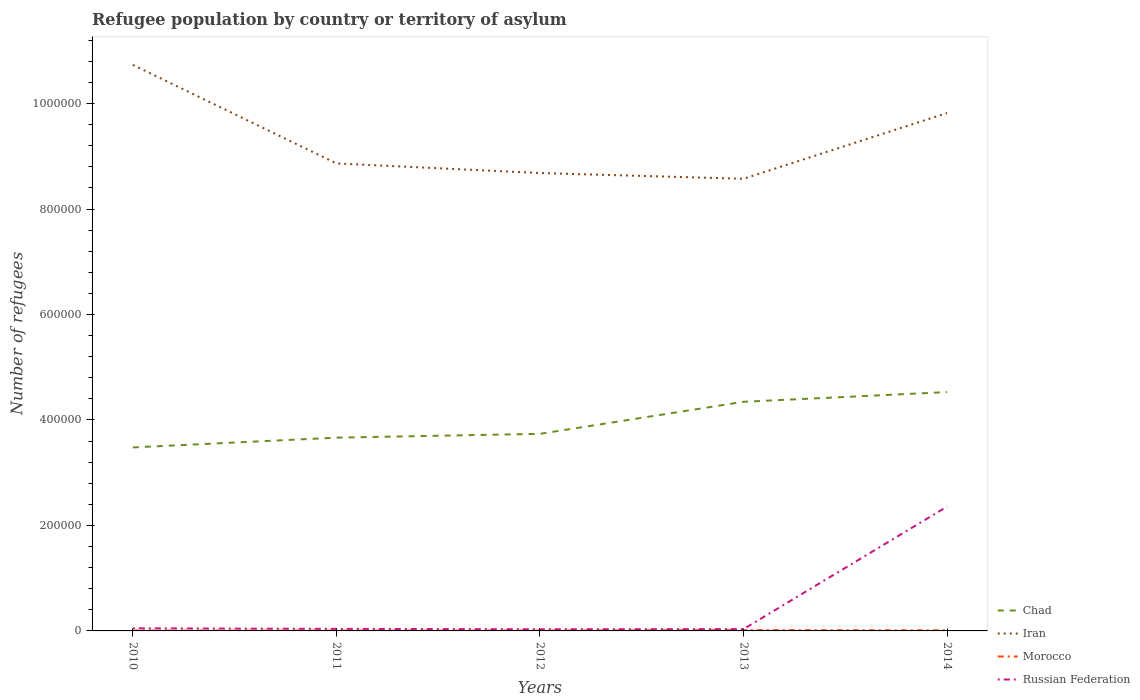Does the line corresponding to Morocco intersect with the line corresponding to Chad?
Offer a very short reply. No. Is the number of lines equal to the number of legend labels?
Your response must be concise. Yes. Across all years, what is the maximum number of refugees in Russian Federation?
Offer a terse response. 3178. In which year was the number of refugees in Morocco maximum?
Provide a short and direct response. 2011. What is the total number of refugees in Russian Federation in the graph?
Offer a very short reply. 1744. What is the difference between the highest and the second highest number of refugees in Iran?
Offer a terse response. 2.16e+05. How many lines are there?
Ensure brevity in your answer.  4. What is the difference between two consecutive major ticks on the Y-axis?
Your answer should be compact. 2.00e+05. Where does the legend appear in the graph?
Offer a very short reply. Bottom right. What is the title of the graph?
Make the answer very short. Refugee population by country or territory of asylum. What is the label or title of the Y-axis?
Give a very brief answer. Number of refugees. What is the Number of refugees in Chad in 2010?
Your response must be concise. 3.48e+05. What is the Number of refugees in Iran in 2010?
Your answer should be very brief. 1.07e+06. What is the Number of refugees in Morocco in 2010?
Your answer should be compact. 792. What is the Number of refugees in Russian Federation in 2010?
Your response must be concise. 4922. What is the Number of refugees in Chad in 2011?
Provide a short and direct response. 3.66e+05. What is the Number of refugees of Iran in 2011?
Offer a very short reply. 8.86e+05. What is the Number of refugees of Morocco in 2011?
Ensure brevity in your answer.  736. What is the Number of refugees of Russian Federation in 2011?
Provide a short and direct response. 3914. What is the Number of refugees of Chad in 2012?
Provide a short and direct response. 3.74e+05. What is the Number of refugees of Iran in 2012?
Keep it short and to the point. 8.68e+05. What is the Number of refugees of Morocco in 2012?
Provide a short and direct response. 744. What is the Number of refugees in Russian Federation in 2012?
Make the answer very short. 3178. What is the Number of refugees of Chad in 2013?
Provide a succinct answer. 4.34e+05. What is the Number of refugees in Iran in 2013?
Provide a succinct answer. 8.57e+05. What is the Number of refugees of Morocco in 2013?
Give a very brief answer. 1470. What is the Number of refugees in Russian Federation in 2013?
Keep it short and to the point. 3458. What is the Number of refugees in Chad in 2014?
Make the answer very short. 4.53e+05. What is the Number of refugees in Iran in 2014?
Provide a succinct answer. 9.82e+05. What is the Number of refugees of Morocco in 2014?
Ensure brevity in your answer.  1216. What is the Number of refugees of Russian Federation in 2014?
Ensure brevity in your answer.  2.36e+05. Across all years, what is the maximum Number of refugees in Chad?
Your response must be concise. 4.53e+05. Across all years, what is the maximum Number of refugees in Iran?
Offer a very short reply. 1.07e+06. Across all years, what is the maximum Number of refugees of Morocco?
Give a very brief answer. 1470. Across all years, what is the maximum Number of refugees of Russian Federation?
Offer a very short reply. 2.36e+05. Across all years, what is the minimum Number of refugees of Chad?
Offer a terse response. 3.48e+05. Across all years, what is the minimum Number of refugees of Iran?
Your answer should be very brief. 8.57e+05. Across all years, what is the minimum Number of refugees in Morocco?
Keep it short and to the point. 736. Across all years, what is the minimum Number of refugees of Russian Federation?
Offer a terse response. 3178. What is the total Number of refugees of Chad in the graph?
Keep it short and to the point. 1.98e+06. What is the total Number of refugees of Iran in the graph?
Provide a short and direct response. 4.67e+06. What is the total Number of refugees of Morocco in the graph?
Give a very brief answer. 4958. What is the total Number of refugees in Russian Federation in the graph?
Your response must be concise. 2.51e+05. What is the difference between the Number of refugees of Chad in 2010 and that in 2011?
Provide a succinct answer. -1.86e+04. What is the difference between the Number of refugees in Iran in 2010 and that in 2011?
Ensure brevity in your answer.  1.87e+05. What is the difference between the Number of refugees in Morocco in 2010 and that in 2011?
Keep it short and to the point. 56. What is the difference between the Number of refugees of Russian Federation in 2010 and that in 2011?
Your answer should be very brief. 1008. What is the difference between the Number of refugees in Chad in 2010 and that in 2012?
Your answer should be very brief. -2.58e+04. What is the difference between the Number of refugees in Iran in 2010 and that in 2012?
Make the answer very short. 2.05e+05. What is the difference between the Number of refugees of Russian Federation in 2010 and that in 2012?
Give a very brief answer. 1744. What is the difference between the Number of refugees in Chad in 2010 and that in 2013?
Your answer should be very brief. -8.65e+04. What is the difference between the Number of refugees in Iran in 2010 and that in 2013?
Give a very brief answer. 2.16e+05. What is the difference between the Number of refugees of Morocco in 2010 and that in 2013?
Provide a succinct answer. -678. What is the difference between the Number of refugees of Russian Federation in 2010 and that in 2013?
Your response must be concise. 1464. What is the difference between the Number of refugees of Chad in 2010 and that in 2014?
Give a very brief answer. -1.05e+05. What is the difference between the Number of refugees of Iran in 2010 and that in 2014?
Give a very brief answer. 9.13e+04. What is the difference between the Number of refugees in Morocco in 2010 and that in 2014?
Offer a terse response. -424. What is the difference between the Number of refugees in Russian Federation in 2010 and that in 2014?
Your answer should be very brief. -2.31e+05. What is the difference between the Number of refugees in Chad in 2011 and that in 2012?
Offer a terse response. -7201. What is the difference between the Number of refugees of Iran in 2011 and that in 2012?
Your answer should be compact. 1.82e+04. What is the difference between the Number of refugees of Russian Federation in 2011 and that in 2012?
Give a very brief answer. 736. What is the difference between the Number of refugees of Chad in 2011 and that in 2013?
Your answer should be compact. -6.80e+04. What is the difference between the Number of refugees in Iran in 2011 and that in 2013?
Provide a succinct answer. 2.91e+04. What is the difference between the Number of refugees of Morocco in 2011 and that in 2013?
Your response must be concise. -734. What is the difference between the Number of refugees in Russian Federation in 2011 and that in 2013?
Make the answer very short. 456. What is the difference between the Number of refugees in Chad in 2011 and that in 2014?
Your answer should be compact. -8.64e+04. What is the difference between the Number of refugees in Iran in 2011 and that in 2014?
Make the answer very short. -9.56e+04. What is the difference between the Number of refugees in Morocco in 2011 and that in 2014?
Your answer should be compact. -480. What is the difference between the Number of refugees in Russian Federation in 2011 and that in 2014?
Make the answer very short. -2.32e+05. What is the difference between the Number of refugees in Chad in 2012 and that in 2013?
Your response must be concise. -6.08e+04. What is the difference between the Number of refugees in Iran in 2012 and that in 2013?
Give a very brief answer. 1.09e+04. What is the difference between the Number of refugees of Morocco in 2012 and that in 2013?
Your answer should be very brief. -726. What is the difference between the Number of refugees of Russian Federation in 2012 and that in 2013?
Make the answer very short. -280. What is the difference between the Number of refugees in Chad in 2012 and that in 2014?
Ensure brevity in your answer.  -7.92e+04. What is the difference between the Number of refugees of Iran in 2012 and that in 2014?
Offer a terse response. -1.14e+05. What is the difference between the Number of refugees in Morocco in 2012 and that in 2014?
Give a very brief answer. -472. What is the difference between the Number of refugees of Russian Federation in 2012 and that in 2014?
Your response must be concise. -2.33e+05. What is the difference between the Number of refugees of Chad in 2013 and that in 2014?
Keep it short and to the point. -1.84e+04. What is the difference between the Number of refugees in Iran in 2013 and that in 2014?
Your answer should be very brief. -1.25e+05. What is the difference between the Number of refugees in Morocco in 2013 and that in 2014?
Provide a succinct answer. 254. What is the difference between the Number of refugees of Russian Federation in 2013 and that in 2014?
Provide a short and direct response. -2.32e+05. What is the difference between the Number of refugees of Chad in 2010 and the Number of refugees of Iran in 2011?
Your answer should be very brief. -5.39e+05. What is the difference between the Number of refugees of Chad in 2010 and the Number of refugees of Morocco in 2011?
Give a very brief answer. 3.47e+05. What is the difference between the Number of refugees of Chad in 2010 and the Number of refugees of Russian Federation in 2011?
Your answer should be compact. 3.44e+05. What is the difference between the Number of refugees of Iran in 2010 and the Number of refugees of Morocco in 2011?
Ensure brevity in your answer.  1.07e+06. What is the difference between the Number of refugees of Iran in 2010 and the Number of refugees of Russian Federation in 2011?
Provide a short and direct response. 1.07e+06. What is the difference between the Number of refugees in Morocco in 2010 and the Number of refugees in Russian Federation in 2011?
Give a very brief answer. -3122. What is the difference between the Number of refugees in Chad in 2010 and the Number of refugees in Iran in 2012?
Your answer should be very brief. -5.20e+05. What is the difference between the Number of refugees of Chad in 2010 and the Number of refugees of Morocco in 2012?
Offer a very short reply. 3.47e+05. What is the difference between the Number of refugees in Chad in 2010 and the Number of refugees in Russian Federation in 2012?
Offer a very short reply. 3.45e+05. What is the difference between the Number of refugees of Iran in 2010 and the Number of refugees of Morocco in 2012?
Your answer should be very brief. 1.07e+06. What is the difference between the Number of refugees in Iran in 2010 and the Number of refugees in Russian Federation in 2012?
Give a very brief answer. 1.07e+06. What is the difference between the Number of refugees of Morocco in 2010 and the Number of refugees of Russian Federation in 2012?
Offer a terse response. -2386. What is the difference between the Number of refugees in Chad in 2010 and the Number of refugees in Iran in 2013?
Provide a succinct answer. -5.09e+05. What is the difference between the Number of refugees in Chad in 2010 and the Number of refugees in Morocco in 2013?
Offer a very short reply. 3.46e+05. What is the difference between the Number of refugees in Chad in 2010 and the Number of refugees in Russian Federation in 2013?
Make the answer very short. 3.44e+05. What is the difference between the Number of refugees of Iran in 2010 and the Number of refugees of Morocco in 2013?
Provide a short and direct response. 1.07e+06. What is the difference between the Number of refugees of Iran in 2010 and the Number of refugees of Russian Federation in 2013?
Offer a very short reply. 1.07e+06. What is the difference between the Number of refugees of Morocco in 2010 and the Number of refugees of Russian Federation in 2013?
Make the answer very short. -2666. What is the difference between the Number of refugees of Chad in 2010 and the Number of refugees of Iran in 2014?
Provide a short and direct response. -6.34e+05. What is the difference between the Number of refugees of Chad in 2010 and the Number of refugees of Morocco in 2014?
Offer a terse response. 3.47e+05. What is the difference between the Number of refugees of Chad in 2010 and the Number of refugees of Russian Federation in 2014?
Provide a succinct answer. 1.12e+05. What is the difference between the Number of refugees in Iran in 2010 and the Number of refugees in Morocco in 2014?
Make the answer very short. 1.07e+06. What is the difference between the Number of refugees in Iran in 2010 and the Number of refugees in Russian Federation in 2014?
Ensure brevity in your answer.  8.38e+05. What is the difference between the Number of refugees in Morocco in 2010 and the Number of refugees in Russian Federation in 2014?
Offer a very short reply. -2.35e+05. What is the difference between the Number of refugees of Chad in 2011 and the Number of refugees of Iran in 2012?
Provide a short and direct response. -5.02e+05. What is the difference between the Number of refugees in Chad in 2011 and the Number of refugees in Morocco in 2012?
Keep it short and to the point. 3.66e+05. What is the difference between the Number of refugees in Chad in 2011 and the Number of refugees in Russian Federation in 2012?
Offer a terse response. 3.63e+05. What is the difference between the Number of refugees in Iran in 2011 and the Number of refugees in Morocco in 2012?
Offer a very short reply. 8.86e+05. What is the difference between the Number of refugees of Iran in 2011 and the Number of refugees of Russian Federation in 2012?
Your answer should be very brief. 8.83e+05. What is the difference between the Number of refugees of Morocco in 2011 and the Number of refugees of Russian Federation in 2012?
Provide a short and direct response. -2442. What is the difference between the Number of refugees of Chad in 2011 and the Number of refugees of Iran in 2013?
Offer a terse response. -4.91e+05. What is the difference between the Number of refugees of Chad in 2011 and the Number of refugees of Morocco in 2013?
Make the answer very short. 3.65e+05. What is the difference between the Number of refugees in Chad in 2011 and the Number of refugees in Russian Federation in 2013?
Provide a short and direct response. 3.63e+05. What is the difference between the Number of refugees of Iran in 2011 and the Number of refugees of Morocco in 2013?
Offer a very short reply. 8.85e+05. What is the difference between the Number of refugees in Iran in 2011 and the Number of refugees in Russian Federation in 2013?
Your answer should be very brief. 8.83e+05. What is the difference between the Number of refugees in Morocco in 2011 and the Number of refugees in Russian Federation in 2013?
Offer a very short reply. -2722. What is the difference between the Number of refugees of Chad in 2011 and the Number of refugees of Iran in 2014?
Your answer should be compact. -6.16e+05. What is the difference between the Number of refugees of Chad in 2011 and the Number of refugees of Morocco in 2014?
Offer a very short reply. 3.65e+05. What is the difference between the Number of refugees of Chad in 2011 and the Number of refugees of Russian Federation in 2014?
Give a very brief answer. 1.31e+05. What is the difference between the Number of refugees of Iran in 2011 and the Number of refugees of Morocco in 2014?
Your response must be concise. 8.85e+05. What is the difference between the Number of refugees of Iran in 2011 and the Number of refugees of Russian Federation in 2014?
Make the answer very short. 6.51e+05. What is the difference between the Number of refugees in Morocco in 2011 and the Number of refugees in Russian Federation in 2014?
Your answer should be compact. -2.35e+05. What is the difference between the Number of refugees in Chad in 2012 and the Number of refugees in Iran in 2013?
Offer a very short reply. -4.84e+05. What is the difference between the Number of refugees of Chad in 2012 and the Number of refugees of Morocco in 2013?
Offer a terse response. 3.72e+05. What is the difference between the Number of refugees of Chad in 2012 and the Number of refugees of Russian Federation in 2013?
Make the answer very short. 3.70e+05. What is the difference between the Number of refugees of Iran in 2012 and the Number of refugees of Morocco in 2013?
Your answer should be compact. 8.67e+05. What is the difference between the Number of refugees in Iran in 2012 and the Number of refugees in Russian Federation in 2013?
Make the answer very short. 8.65e+05. What is the difference between the Number of refugees of Morocco in 2012 and the Number of refugees of Russian Federation in 2013?
Ensure brevity in your answer.  -2714. What is the difference between the Number of refugees in Chad in 2012 and the Number of refugees in Iran in 2014?
Provide a succinct answer. -6.08e+05. What is the difference between the Number of refugees in Chad in 2012 and the Number of refugees in Morocco in 2014?
Your response must be concise. 3.72e+05. What is the difference between the Number of refugees in Chad in 2012 and the Number of refugees in Russian Federation in 2014?
Your response must be concise. 1.38e+05. What is the difference between the Number of refugees of Iran in 2012 and the Number of refugees of Morocco in 2014?
Provide a short and direct response. 8.67e+05. What is the difference between the Number of refugees in Iran in 2012 and the Number of refugees in Russian Federation in 2014?
Give a very brief answer. 6.32e+05. What is the difference between the Number of refugees of Morocco in 2012 and the Number of refugees of Russian Federation in 2014?
Your answer should be very brief. -2.35e+05. What is the difference between the Number of refugees in Chad in 2013 and the Number of refugees in Iran in 2014?
Your answer should be compact. -5.48e+05. What is the difference between the Number of refugees in Chad in 2013 and the Number of refugees in Morocco in 2014?
Ensure brevity in your answer.  4.33e+05. What is the difference between the Number of refugees of Chad in 2013 and the Number of refugees of Russian Federation in 2014?
Offer a very short reply. 1.99e+05. What is the difference between the Number of refugees in Iran in 2013 and the Number of refugees in Morocco in 2014?
Give a very brief answer. 8.56e+05. What is the difference between the Number of refugees of Iran in 2013 and the Number of refugees of Russian Federation in 2014?
Make the answer very short. 6.22e+05. What is the difference between the Number of refugees of Morocco in 2013 and the Number of refugees of Russian Federation in 2014?
Give a very brief answer. -2.34e+05. What is the average Number of refugees in Chad per year?
Provide a short and direct response. 3.95e+05. What is the average Number of refugees of Iran per year?
Offer a very short reply. 9.33e+05. What is the average Number of refugees of Morocco per year?
Keep it short and to the point. 991.6. What is the average Number of refugees in Russian Federation per year?
Your answer should be very brief. 5.02e+04. In the year 2010, what is the difference between the Number of refugees in Chad and Number of refugees in Iran?
Your response must be concise. -7.25e+05. In the year 2010, what is the difference between the Number of refugees in Chad and Number of refugees in Morocco?
Provide a succinct answer. 3.47e+05. In the year 2010, what is the difference between the Number of refugees in Chad and Number of refugees in Russian Federation?
Offer a very short reply. 3.43e+05. In the year 2010, what is the difference between the Number of refugees in Iran and Number of refugees in Morocco?
Offer a terse response. 1.07e+06. In the year 2010, what is the difference between the Number of refugees of Iran and Number of refugees of Russian Federation?
Make the answer very short. 1.07e+06. In the year 2010, what is the difference between the Number of refugees in Morocco and Number of refugees in Russian Federation?
Make the answer very short. -4130. In the year 2011, what is the difference between the Number of refugees in Chad and Number of refugees in Iran?
Ensure brevity in your answer.  -5.20e+05. In the year 2011, what is the difference between the Number of refugees in Chad and Number of refugees in Morocco?
Provide a succinct answer. 3.66e+05. In the year 2011, what is the difference between the Number of refugees in Chad and Number of refugees in Russian Federation?
Offer a very short reply. 3.63e+05. In the year 2011, what is the difference between the Number of refugees in Iran and Number of refugees in Morocco?
Your response must be concise. 8.86e+05. In the year 2011, what is the difference between the Number of refugees of Iran and Number of refugees of Russian Federation?
Provide a succinct answer. 8.83e+05. In the year 2011, what is the difference between the Number of refugees of Morocco and Number of refugees of Russian Federation?
Make the answer very short. -3178. In the year 2012, what is the difference between the Number of refugees of Chad and Number of refugees of Iran?
Offer a very short reply. -4.95e+05. In the year 2012, what is the difference between the Number of refugees of Chad and Number of refugees of Morocco?
Your answer should be compact. 3.73e+05. In the year 2012, what is the difference between the Number of refugees in Chad and Number of refugees in Russian Federation?
Make the answer very short. 3.71e+05. In the year 2012, what is the difference between the Number of refugees of Iran and Number of refugees of Morocco?
Offer a terse response. 8.67e+05. In the year 2012, what is the difference between the Number of refugees of Iran and Number of refugees of Russian Federation?
Provide a succinct answer. 8.65e+05. In the year 2012, what is the difference between the Number of refugees in Morocco and Number of refugees in Russian Federation?
Provide a short and direct response. -2434. In the year 2013, what is the difference between the Number of refugees in Chad and Number of refugees in Iran?
Provide a succinct answer. -4.23e+05. In the year 2013, what is the difference between the Number of refugees of Chad and Number of refugees of Morocco?
Give a very brief answer. 4.33e+05. In the year 2013, what is the difference between the Number of refugees of Chad and Number of refugees of Russian Federation?
Your answer should be compact. 4.31e+05. In the year 2013, what is the difference between the Number of refugees in Iran and Number of refugees in Morocco?
Offer a very short reply. 8.56e+05. In the year 2013, what is the difference between the Number of refugees of Iran and Number of refugees of Russian Federation?
Make the answer very short. 8.54e+05. In the year 2013, what is the difference between the Number of refugees in Morocco and Number of refugees in Russian Federation?
Offer a terse response. -1988. In the year 2014, what is the difference between the Number of refugees of Chad and Number of refugees of Iran?
Give a very brief answer. -5.29e+05. In the year 2014, what is the difference between the Number of refugees in Chad and Number of refugees in Morocco?
Offer a terse response. 4.52e+05. In the year 2014, what is the difference between the Number of refugees in Chad and Number of refugees in Russian Federation?
Your response must be concise. 2.17e+05. In the year 2014, what is the difference between the Number of refugees of Iran and Number of refugees of Morocco?
Provide a short and direct response. 9.81e+05. In the year 2014, what is the difference between the Number of refugees of Iran and Number of refugees of Russian Federation?
Your answer should be very brief. 7.46e+05. In the year 2014, what is the difference between the Number of refugees in Morocco and Number of refugees in Russian Federation?
Ensure brevity in your answer.  -2.35e+05. What is the ratio of the Number of refugees of Chad in 2010 to that in 2011?
Your answer should be very brief. 0.95. What is the ratio of the Number of refugees of Iran in 2010 to that in 2011?
Ensure brevity in your answer.  1.21. What is the ratio of the Number of refugees of Morocco in 2010 to that in 2011?
Offer a terse response. 1.08. What is the ratio of the Number of refugees of Russian Federation in 2010 to that in 2011?
Your response must be concise. 1.26. What is the ratio of the Number of refugees in Chad in 2010 to that in 2012?
Offer a terse response. 0.93. What is the ratio of the Number of refugees of Iran in 2010 to that in 2012?
Provide a short and direct response. 1.24. What is the ratio of the Number of refugees in Morocco in 2010 to that in 2012?
Ensure brevity in your answer.  1.06. What is the ratio of the Number of refugees in Russian Federation in 2010 to that in 2012?
Your answer should be compact. 1.55. What is the ratio of the Number of refugees of Chad in 2010 to that in 2013?
Offer a terse response. 0.8. What is the ratio of the Number of refugees of Iran in 2010 to that in 2013?
Provide a short and direct response. 1.25. What is the ratio of the Number of refugees in Morocco in 2010 to that in 2013?
Make the answer very short. 0.54. What is the ratio of the Number of refugees of Russian Federation in 2010 to that in 2013?
Ensure brevity in your answer.  1.42. What is the ratio of the Number of refugees of Chad in 2010 to that in 2014?
Offer a very short reply. 0.77. What is the ratio of the Number of refugees of Iran in 2010 to that in 2014?
Give a very brief answer. 1.09. What is the ratio of the Number of refugees of Morocco in 2010 to that in 2014?
Make the answer very short. 0.65. What is the ratio of the Number of refugees of Russian Federation in 2010 to that in 2014?
Provide a short and direct response. 0.02. What is the ratio of the Number of refugees of Chad in 2011 to that in 2012?
Ensure brevity in your answer.  0.98. What is the ratio of the Number of refugees in Russian Federation in 2011 to that in 2012?
Make the answer very short. 1.23. What is the ratio of the Number of refugees in Chad in 2011 to that in 2013?
Ensure brevity in your answer.  0.84. What is the ratio of the Number of refugees in Iran in 2011 to that in 2013?
Ensure brevity in your answer.  1.03. What is the ratio of the Number of refugees of Morocco in 2011 to that in 2013?
Your response must be concise. 0.5. What is the ratio of the Number of refugees in Russian Federation in 2011 to that in 2013?
Your response must be concise. 1.13. What is the ratio of the Number of refugees of Chad in 2011 to that in 2014?
Provide a short and direct response. 0.81. What is the ratio of the Number of refugees in Iran in 2011 to that in 2014?
Offer a very short reply. 0.9. What is the ratio of the Number of refugees of Morocco in 2011 to that in 2014?
Offer a very short reply. 0.61. What is the ratio of the Number of refugees in Russian Federation in 2011 to that in 2014?
Give a very brief answer. 0.02. What is the ratio of the Number of refugees in Chad in 2012 to that in 2013?
Offer a terse response. 0.86. What is the ratio of the Number of refugees in Iran in 2012 to that in 2013?
Your answer should be compact. 1.01. What is the ratio of the Number of refugees of Morocco in 2012 to that in 2013?
Ensure brevity in your answer.  0.51. What is the ratio of the Number of refugees of Russian Federation in 2012 to that in 2013?
Provide a short and direct response. 0.92. What is the ratio of the Number of refugees in Chad in 2012 to that in 2014?
Provide a succinct answer. 0.83. What is the ratio of the Number of refugees in Iran in 2012 to that in 2014?
Offer a very short reply. 0.88. What is the ratio of the Number of refugees of Morocco in 2012 to that in 2014?
Ensure brevity in your answer.  0.61. What is the ratio of the Number of refugees in Russian Federation in 2012 to that in 2014?
Give a very brief answer. 0.01. What is the ratio of the Number of refugees in Chad in 2013 to that in 2014?
Make the answer very short. 0.96. What is the ratio of the Number of refugees in Iran in 2013 to that in 2014?
Your response must be concise. 0.87. What is the ratio of the Number of refugees in Morocco in 2013 to that in 2014?
Your answer should be very brief. 1.21. What is the ratio of the Number of refugees in Russian Federation in 2013 to that in 2014?
Keep it short and to the point. 0.01. What is the difference between the highest and the second highest Number of refugees of Chad?
Ensure brevity in your answer.  1.84e+04. What is the difference between the highest and the second highest Number of refugees of Iran?
Give a very brief answer. 9.13e+04. What is the difference between the highest and the second highest Number of refugees in Morocco?
Your answer should be compact. 254. What is the difference between the highest and the second highest Number of refugees in Russian Federation?
Provide a short and direct response. 2.31e+05. What is the difference between the highest and the lowest Number of refugees in Chad?
Offer a terse response. 1.05e+05. What is the difference between the highest and the lowest Number of refugees in Iran?
Your answer should be very brief. 2.16e+05. What is the difference between the highest and the lowest Number of refugees in Morocco?
Your answer should be compact. 734. What is the difference between the highest and the lowest Number of refugees of Russian Federation?
Offer a very short reply. 2.33e+05. 